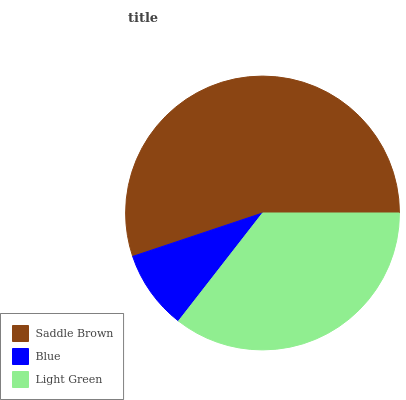Is Blue the minimum?
Answer yes or no. Yes. Is Saddle Brown the maximum?
Answer yes or no. Yes. Is Light Green the minimum?
Answer yes or no. No. Is Light Green the maximum?
Answer yes or no. No. Is Light Green greater than Blue?
Answer yes or no. Yes. Is Blue less than Light Green?
Answer yes or no. Yes. Is Blue greater than Light Green?
Answer yes or no. No. Is Light Green less than Blue?
Answer yes or no. No. Is Light Green the high median?
Answer yes or no. Yes. Is Light Green the low median?
Answer yes or no. Yes. Is Blue the high median?
Answer yes or no. No. Is Blue the low median?
Answer yes or no. No. 